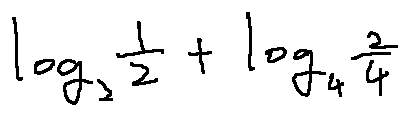Convert formula to latex. <formula><loc_0><loc_0><loc_500><loc_500>\log _ { 2 } \frac { 1 } { 2 } + \log _ { 4 } \frac { 2 } { 4 }</formula> 